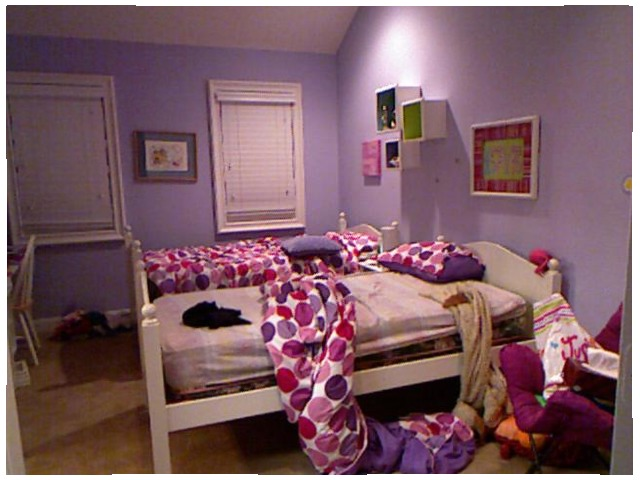<image>
Is the bedsheet under the cot? Yes. The bedsheet is positioned underneath the cot, with the cot above it in the vertical space. Is the pillow on the bed? Yes. Looking at the image, I can see the pillow is positioned on top of the bed, with the bed providing support. 